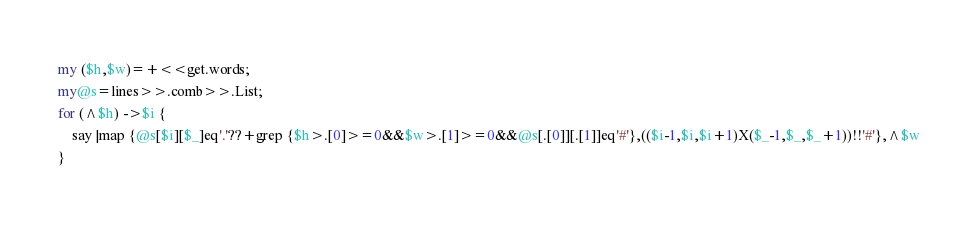<code> <loc_0><loc_0><loc_500><loc_500><_Perl_>my ($h,$w)=+<<get.words;
my@s=lines>>.comb>>.List;
for (^$h) ->$i {
	say |map {@s[$i][$_]eq'.'??+grep {$h>.[0]>=0&&$w>.[1]>=0&&@s[.[0]][.[1]]eq'#'},(($i-1,$i,$i+1)X($_-1,$_,$_+1))!!'#'},^$w
}</code> 